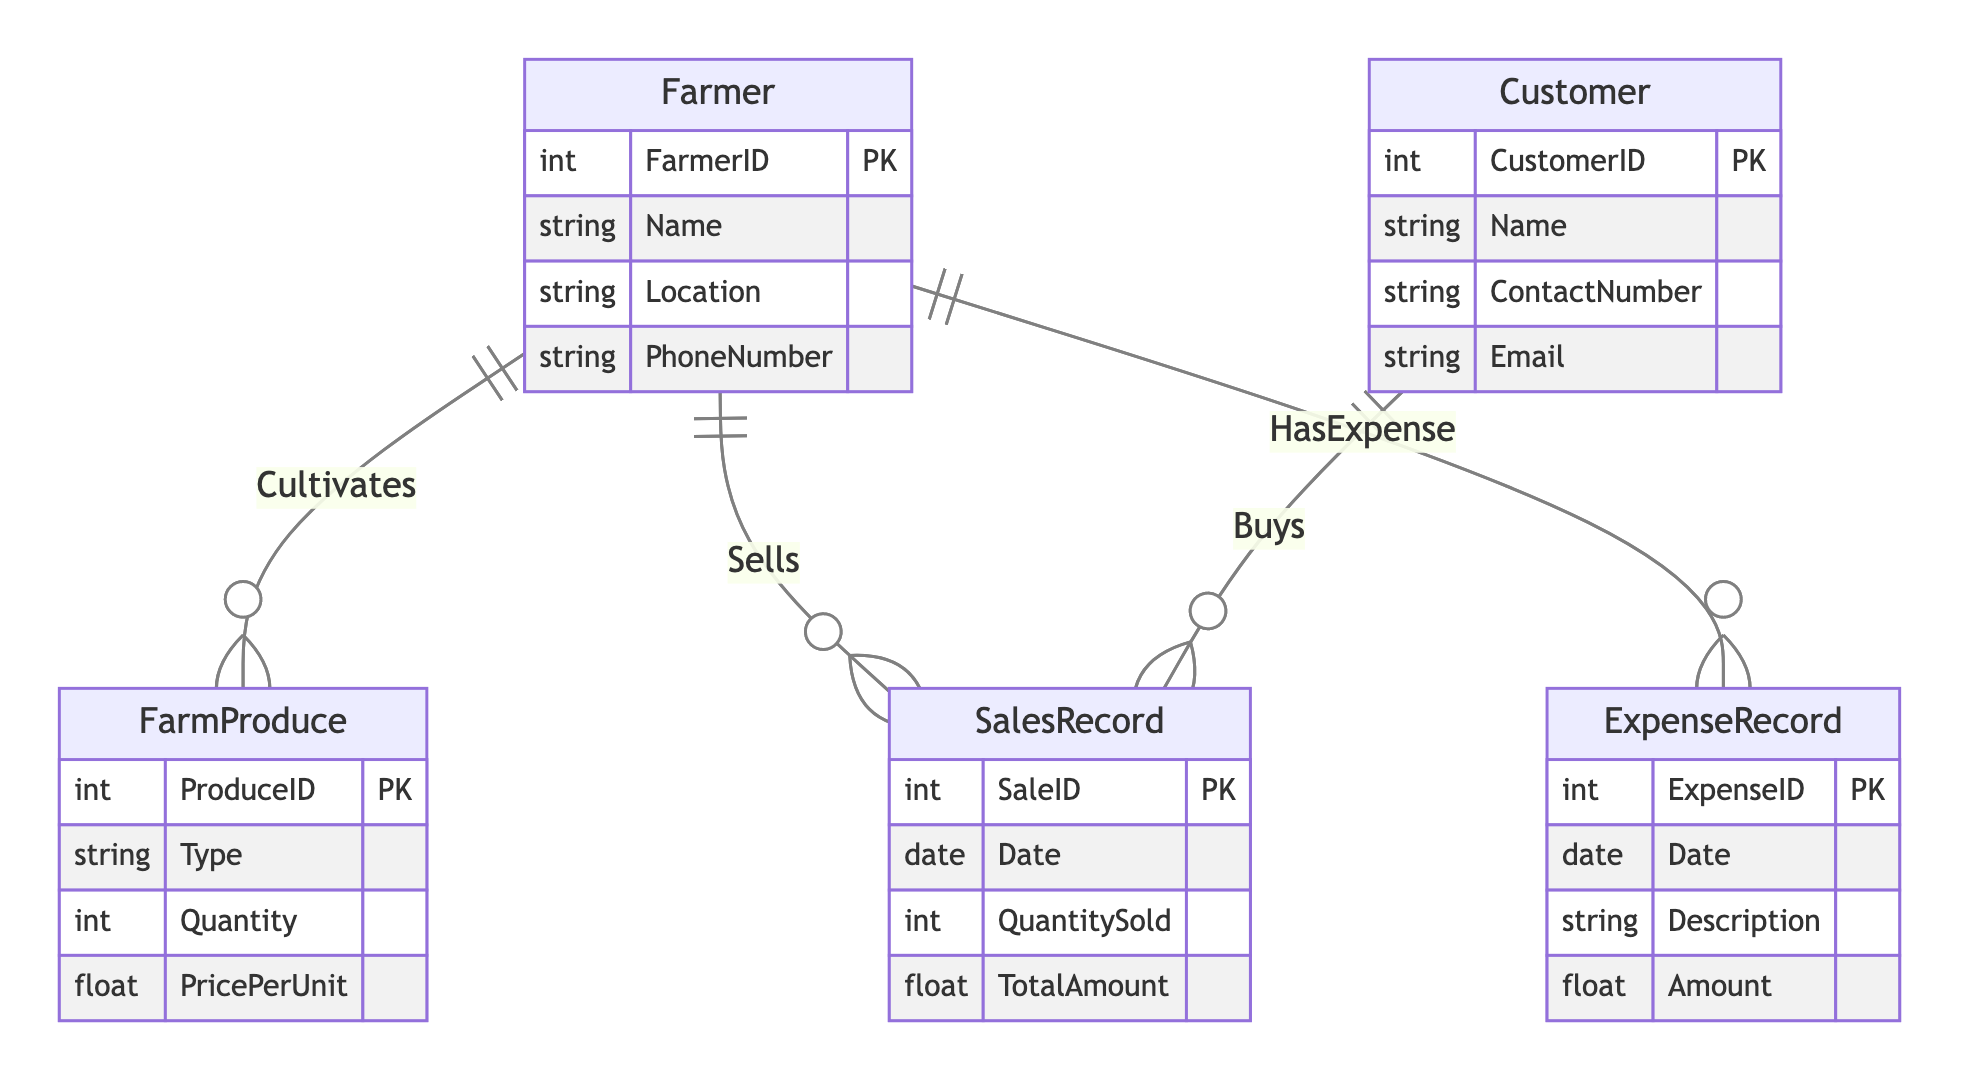What is the primary key of the Farmer entity? The primary key for the Farmer entity is listed as FarmerID, which uniquely identifies each farmer in the database.
Answer: FarmerID How many main entities are documented in the diagram? There are five main entities detailed in the diagram: Farmer, FarmProduce, SalesRecord, Customer, and ExpenseRecord. Counting these gives us a total of five entities.
Answer: Five What relationship connects the Farmer and SalesRecord entities? The relationship between the Farmer and SalesRecord entities is called "Sells," which indicates that a farmer records sales of their products.
Answer: Sells What information is captured by the ExpenseRecord entity? The ExpenseRecord entity captures the Date, Description, and Amount of each expense incurred by the farmer, which is essential for financial tracking.
Answer: Date, Description, Amount Which entity has the relationship "Buys" and what does it connect to in the diagram? The "Buys" relationship is associated with the Customer entity, linking it directly to the SalesRecord, indicating that customers purchase farm produce.
Answer: Customer, SalesRecord What attributes are included in the FarmProduce entity? The attributes for the FarmProduce entity include ProduceID, Type, Quantity, and PricePerUnit, which describe the characteristics of the produce managed by the farmer.
Answer: ProduceID, Type, Quantity, PricePerUnit How is the "Cultivates" relationship described and what does it represent? The "Cultivates" relationship describes how a Farmer interacts with FarmProduce, specifically highlighting the act of farming certain types of produce and also includes an attribute called CultivationDate which records when the produce was cultivated.
Answer: Cultivates What is the function of the SalesRecord entity? The SalesRecord entity serves to document each sale made by the farmer, including date, quantity sold, and total amount, which are critical for tracking financial performance.
Answer: Document sales How many relationships are shown in the diagram connecting the Farmer entity? There are three relationships shown connecting the Farmer entity: "Cultivates," "Sells," and "HasExpense," indicating the various interactions of the farmer with the produce, sales, and expenses.
Answer: Three 